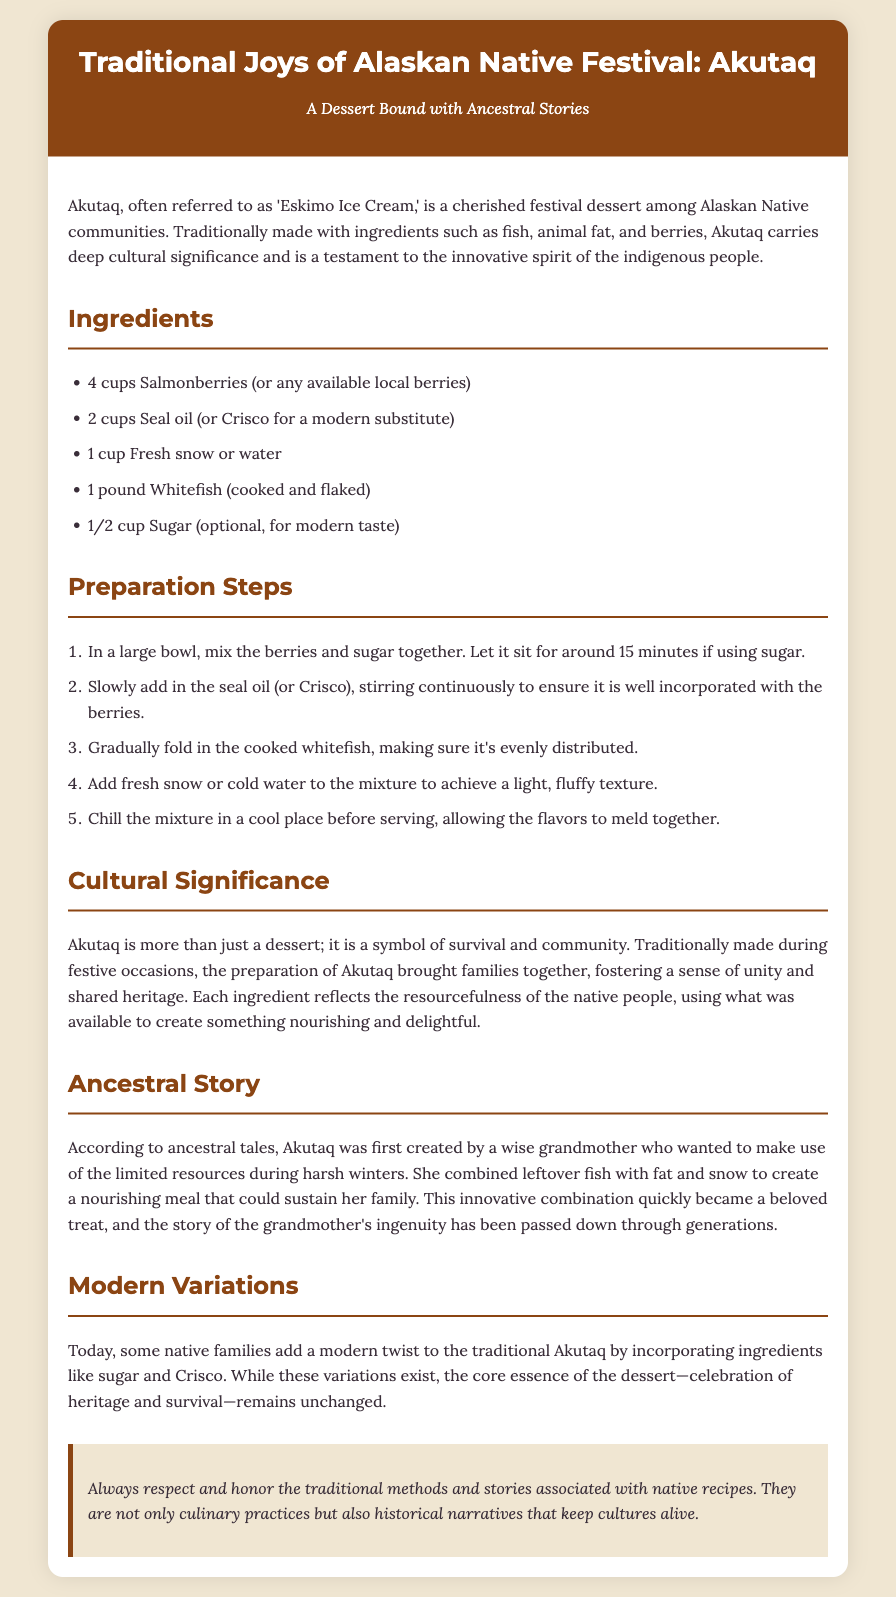What is the name of the dessert? The name of the dessert is mentioned in the title of the document, which is "Traditional Joys of Alaskan Native Festival: Akutaq."
Answer: Akutaq What are the main ingredients used in Akutaq? The main ingredients are listed in the ingredients section and include salmonberries, seal oil, fresh snow or water, whitefish, and sugar.
Answer: Salmonberries, seal oil, fresh snow or water, whitefish, sugar Who is credited with the creation of Akutaq according to the ancestral story? The ancestral story credits a wise grandmother with the creation of Akutaq during harsh winters.
Answer: A wise grandmother What does Akutaq symbolize in Alaskan Native culture? The cultural significance section states that Akutaq symbolizes survival and community.
Answer: Survival and community How much sugar is optional for modern taste? The ingredients list specifies that half a cup of sugar is optional for a modern taste.
Answer: 1/2 cup What is the preparation step involving berries? The first preparation step involves mixing the berries and sugar together and letting it sit for around 15 minutes if using sugar.
Answer: Mix the berries and sugar together In what kind of occasions is Akutaq traditionally made? The cultural significance section mentions that Akutaq is traditionally made during festive occasions.
Answer: Festive occasions What has been incorporated into modern variations of Akutaq? The modern variations section states that ingredients like sugar and Crisco have been incorporated into Akutaq.
Answer: Sugar and Crisco What does the note at the end of the document emphasize? The note emphasizes respecting and honoring traditional methods and stories associated with native recipes.
Answer: Respect and honor traditions 